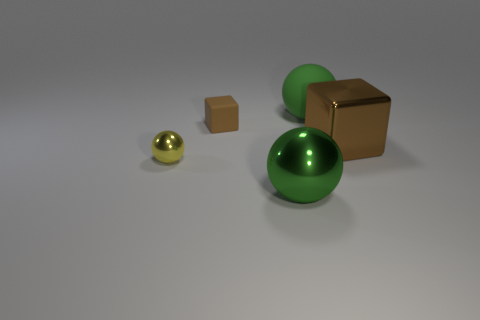What is the material of the large object that is the same color as the big metal ball?
Ensure brevity in your answer.  Rubber. What number of other objects are the same color as the matte sphere?
Offer a terse response. 1. Does the big matte sphere have the same color as the big shiny ball?
Offer a very short reply. Yes. There is a green thing that is behind the yellow ball; does it have the same size as the yellow thing?
Provide a succinct answer. No. There is a thing that is to the left of the green metallic sphere and on the right side of the yellow metal sphere; what is its color?
Keep it short and to the point. Brown. Are the tiny yellow ball and the large brown block made of the same material?
Offer a very short reply. Yes. What number of tiny objects are yellow rubber cylinders or yellow shiny things?
Keep it short and to the point. 1. The big sphere that is the same material as the tiny yellow object is what color?
Give a very brief answer. Green. The sphere that is on the left side of the small brown object is what color?
Your answer should be very brief. Yellow. How many rubber blocks have the same color as the metal cube?
Your answer should be compact. 1. 